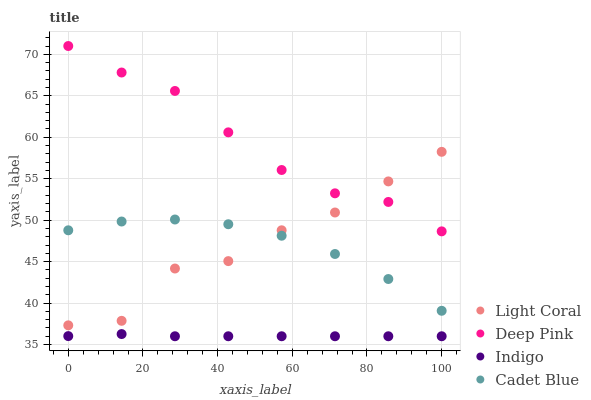Does Indigo have the minimum area under the curve?
Answer yes or no. Yes. Does Deep Pink have the maximum area under the curve?
Answer yes or no. Yes. Does Deep Pink have the minimum area under the curve?
Answer yes or no. No. Does Indigo have the maximum area under the curve?
Answer yes or no. No. Is Indigo the smoothest?
Answer yes or no. Yes. Is Light Coral the roughest?
Answer yes or no. Yes. Is Deep Pink the smoothest?
Answer yes or no. No. Is Deep Pink the roughest?
Answer yes or no. No. Does Indigo have the lowest value?
Answer yes or no. Yes. Does Deep Pink have the lowest value?
Answer yes or no. No. Does Deep Pink have the highest value?
Answer yes or no. Yes. Does Indigo have the highest value?
Answer yes or no. No. Is Cadet Blue less than Deep Pink?
Answer yes or no. Yes. Is Light Coral greater than Indigo?
Answer yes or no. Yes. Does Light Coral intersect Deep Pink?
Answer yes or no. Yes. Is Light Coral less than Deep Pink?
Answer yes or no. No. Is Light Coral greater than Deep Pink?
Answer yes or no. No. Does Cadet Blue intersect Deep Pink?
Answer yes or no. No. 